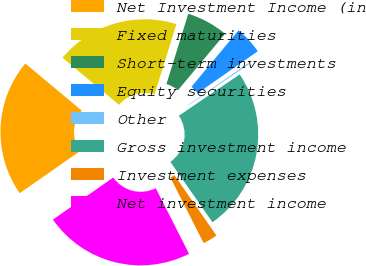<chart> <loc_0><loc_0><loc_500><loc_500><pie_chart><fcel>Net Investment Income (in<fcel>Fixed maturities<fcel>Short-term investments<fcel>Equity securities<fcel>Other<fcel>Gross investment income<fcel>Investment expenses<fcel>Net investment income<nl><fcel>20.76%<fcel>18.73%<fcel>6.27%<fcel>4.24%<fcel>0.19%<fcel>24.81%<fcel>2.22%<fcel>22.78%<nl></chart> 